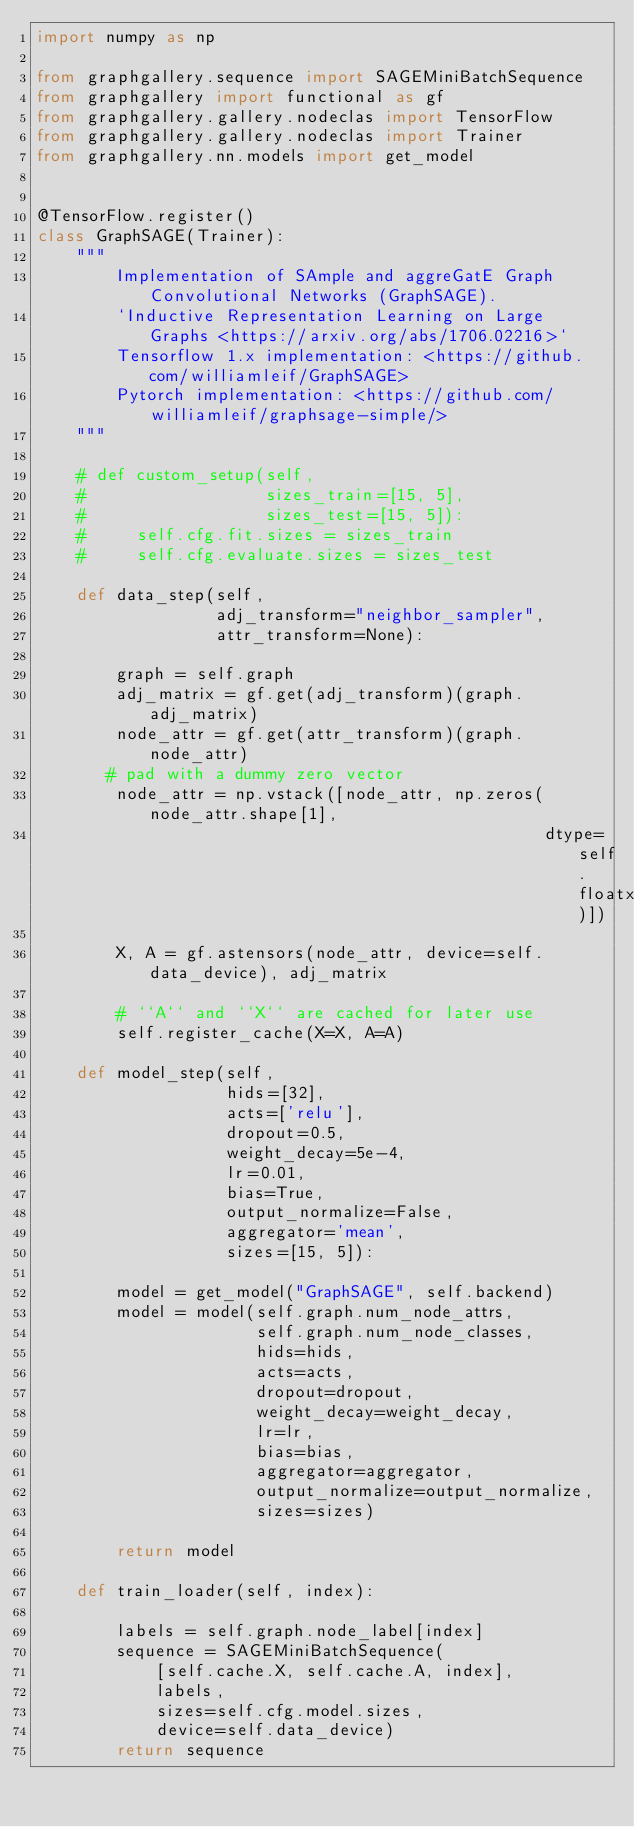Convert code to text. <code><loc_0><loc_0><loc_500><loc_500><_Python_>import numpy as np

from graphgallery.sequence import SAGEMiniBatchSequence
from graphgallery import functional as gf
from graphgallery.gallery.nodeclas import TensorFlow
from graphgallery.gallery.nodeclas import Trainer
from graphgallery.nn.models import get_model


@TensorFlow.register()
class GraphSAGE(Trainer):
    """
        Implementation of SAmple and aggreGatE Graph Convolutional Networks (GraphSAGE). 
        `Inductive Representation Learning on Large Graphs <https://arxiv.org/abs/1706.02216>`
        Tensorflow 1.x implementation: <https://github.com/williamleif/GraphSAGE>
        Pytorch implementation: <https://github.com/williamleif/graphsage-simple/>
    """

    # def custom_setup(self,
    #                  sizes_train=[15, 5],
    #                  sizes_test=[15, 5]):
    #     self.cfg.fit.sizes = sizes_train
    #     self.cfg.evaluate.sizes = sizes_test

    def data_step(self,
                  adj_transform="neighbor_sampler",
                  attr_transform=None):

        graph = self.graph
        adj_matrix = gf.get(adj_transform)(graph.adj_matrix)
        node_attr = gf.get(attr_transform)(graph.node_attr)
       # pad with a dummy zero vector
        node_attr = np.vstack([node_attr, np.zeros(node_attr.shape[1],
                                                   dtype=self.floatx)])

        X, A = gf.astensors(node_attr, device=self.data_device), adj_matrix

        # ``A`` and ``X`` are cached for later use
        self.register_cache(X=X, A=A)

    def model_step(self,
                   hids=[32],
                   acts=['relu'],
                   dropout=0.5,
                   weight_decay=5e-4,
                   lr=0.01,
                   bias=True,
                   output_normalize=False,
                   aggregator='mean',
                   sizes=[15, 5]):

        model = get_model("GraphSAGE", self.backend)
        model = model(self.graph.num_node_attrs,
                      self.graph.num_node_classes,
                      hids=hids,
                      acts=acts,
                      dropout=dropout,
                      weight_decay=weight_decay,
                      lr=lr,
                      bias=bias,
                      aggregator=aggregator,
                      output_normalize=output_normalize,
                      sizes=sizes)

        return model

    def train_loader(self, index):

        labels = self.graph.node_label[index]
        sequence = SAGEMiniBatchSequence(
            [self.cache.X, self.cache.A, index],
            labels,
            sizes=self.cfg.model.sizes,
            device=self.data_device)
        return sequence
</code> 